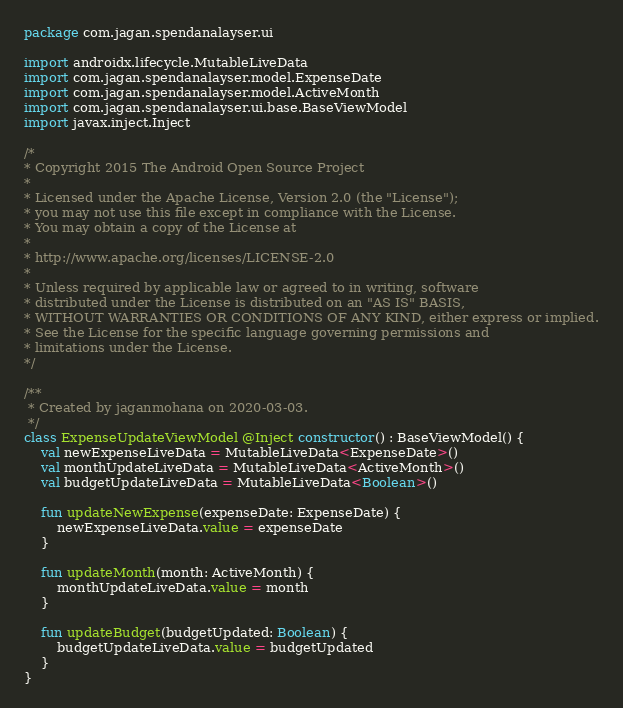<code> <loc_0><loc_0><loc_500><loc_500><_Kotlin_>package com.jagan.spendanalayser.ui

import androidx.lifecycle.MutableLiveData
import com.jagan.spendanalayser.model.ExpenseDate
import com.jagan.spendanalayser.model.ActiveMonth
import com.jagan.spendanalayser.ui.base.BaseViewModel
import javax.inject.Inject

/*
* Copyright 2015 The Android Open Source Project
*
* Licensed under the Apache License, Version 2.0 (the "License");
* you may not use this file except in compliance with the License.
* You may obtain a copy of the License at
*
* http://www.apache.org/licenses/LICENSE-2.0
*
* Unless required by applicable law or agreed to in writing, software
* distributed under the License is distributed on an "AS IS" BASIS,
* WITHOUT WARRANTIES OR CONDITIONS OF ANY KIND, either express or implied.
* See the License for the specific language governing permissions and
* limitations under the License.
*/

/**
 * Created by jaganmohana on 2020-03-03.
 */
class ExpenseUpdateViewModel @Inject constructor() : BaseViewModel() {
    val newExpenseLiveData = MutableLiveData<ExpenseDate>()
    val monthUpdateLiveData = MutableLiveData<ActiveMonth>()
    val budgetUpdateLiveData = MutableLiveData<Boolean>()

    fun updateNewExpense(expenseDate: ExpenseDate) {
        newExpenseLiveData.value = expenseDate
    }

    fun updateMonth(month: ActiveMonth) {
        monthUpdateLiveData.value = month
    }

    fun updateBudget(budgetUpdated: Boolean) {
        budgetUpdateLiveData.value = budgetUpdated
    }
}</code> 